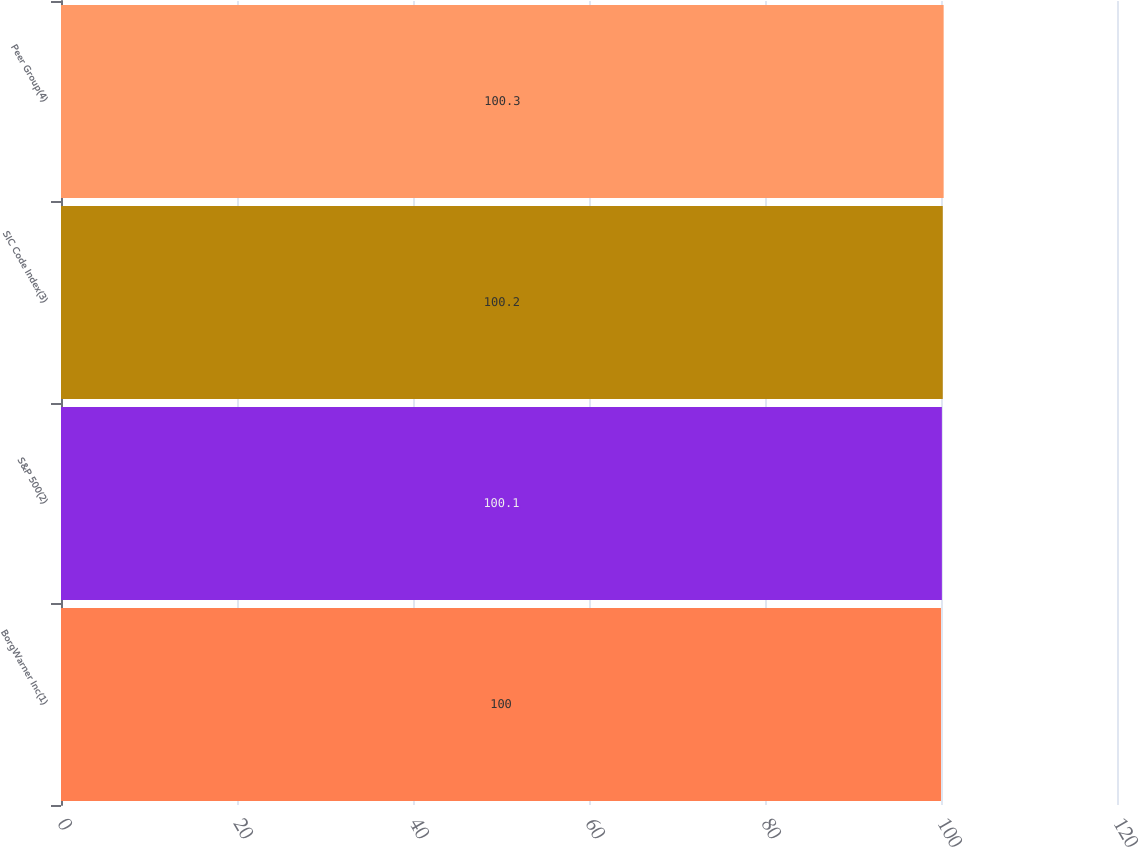Convert chart. <chart><loc_0><loc_0><loc_500><loc_500><bar_chart><fcel>BorgWarner Inc(1)<fcel>S&P 500(2)<fcel>SIC Code Index(3)<fcel>Peer Group(4)<nl><fcel>100<fcel>100.1<fcel>100.2<fcel>100.3<nl></chart> 